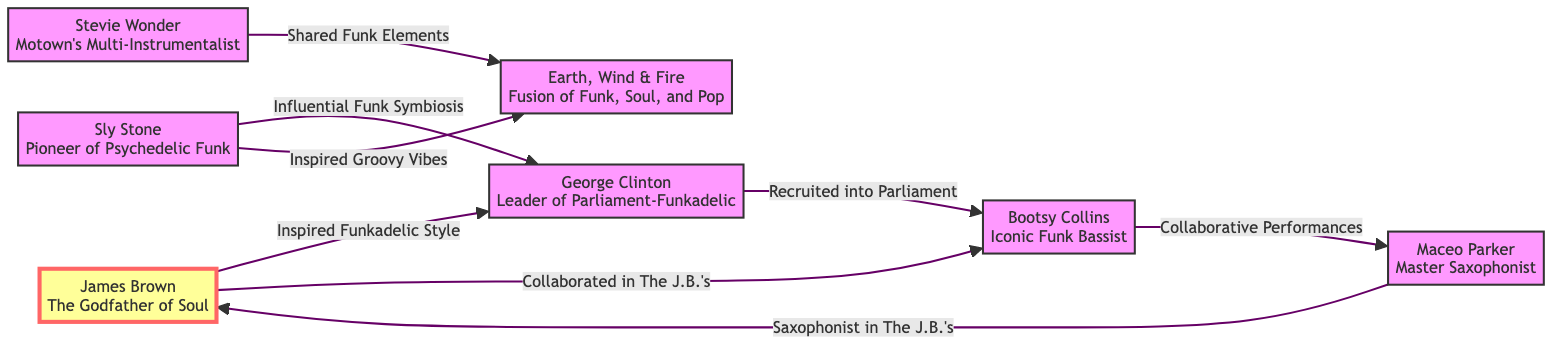What is the central figure in the diagram? The central figure is James Brown, who is labeled as "The Godfather of Soul." The diagram clearly identifies him at the center, denoting his importance in the funk genre.
Answer: James Brown How many musicians are connected directly to James Brown? Three musicians are directly connected to James Brown in the diagram. They are George Clinton, Bootsy Collins, and Maceo Parker, each linked with a specific relationship.
Answer: 3 Who collaborated with James Brown in The J.B.'s? Bootsy Collins is indicated in the diagram as the collaborator with James Brown in The J.B.'s, shown through a direct connection between the two.
Answer: Bootsy Collins Which musician is associated with the "Fusion of Funk, Soul, and Pop"? Earth, Wind & Fire is described in the diagram as having a fusion style, positioned as an influential figure connected to Sly Stone and Stevie Wonder.
Answer: Earth, Wind & Fire What relationship exists between Sly Stone and Earth, Wind & Fire? The diagram states that Sly Stone inspired the groovy vibes of Earth, Wind & Fire, showing a direct influence depicted by an arrow.
Answer: Inspired Groovy Vibes Which musician is connected to both George Clinton and James Brown? Bootsy Collins is the musician connected to both George Clinton (through recruitment into Parliament) and James Brown (through collaboration in The J.B.'s).
Answer: Bootsy Collins How many connections go out of Sly Stone in the diagram? Sly Stone has two connections going out from him, directed toward George Clinton and Earth, Wind & Fire, indicating his influence on both.
Answer: 2 What role does Maceo Parker play in relation to James Brown? Maceo Parker is labeled as the saxophonist in The J.B.'s, indicating his role within James Brown's musical group, which is a direct connection.
Answer: Saxophonist in The J.B.'s Who is noted for shared funk elements with Earth, Wind & Fire? Stevie Wonder is noted in the diagram for sharing funk elements with Earth, Wind & Fire, indicating a collaborative influence on their style.
Answer: Stevie Wonder 